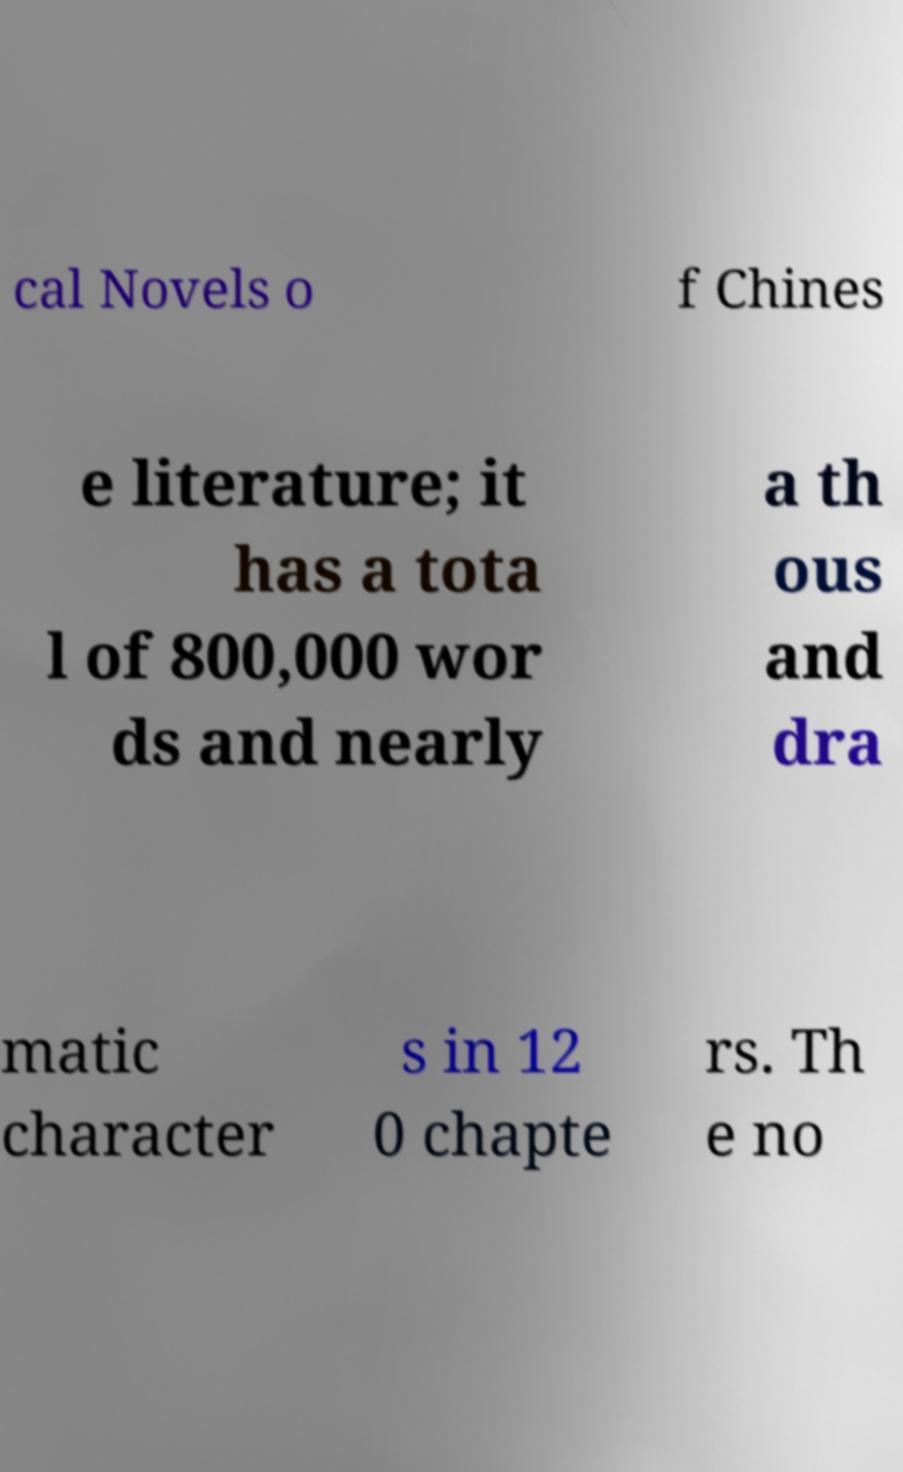Please identify and transcribe the text found in this image. cal Novels o f Chines e literature; it has a tota l of 800,000 wor ds and nearly a th ous and dra matic character s in 12 0 chapte rs. Th e no 